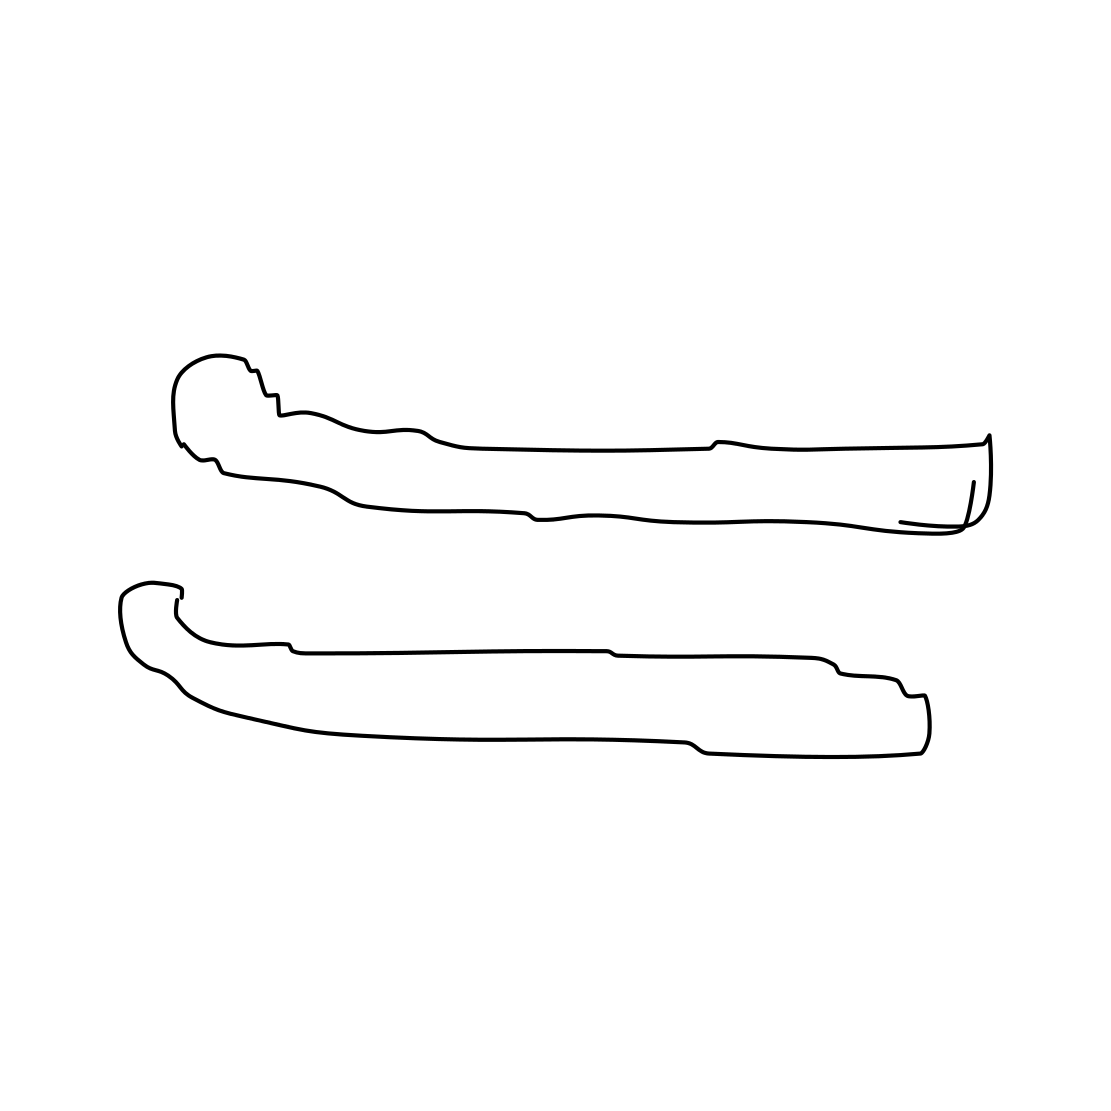In the scene, is a scissors in it? No 